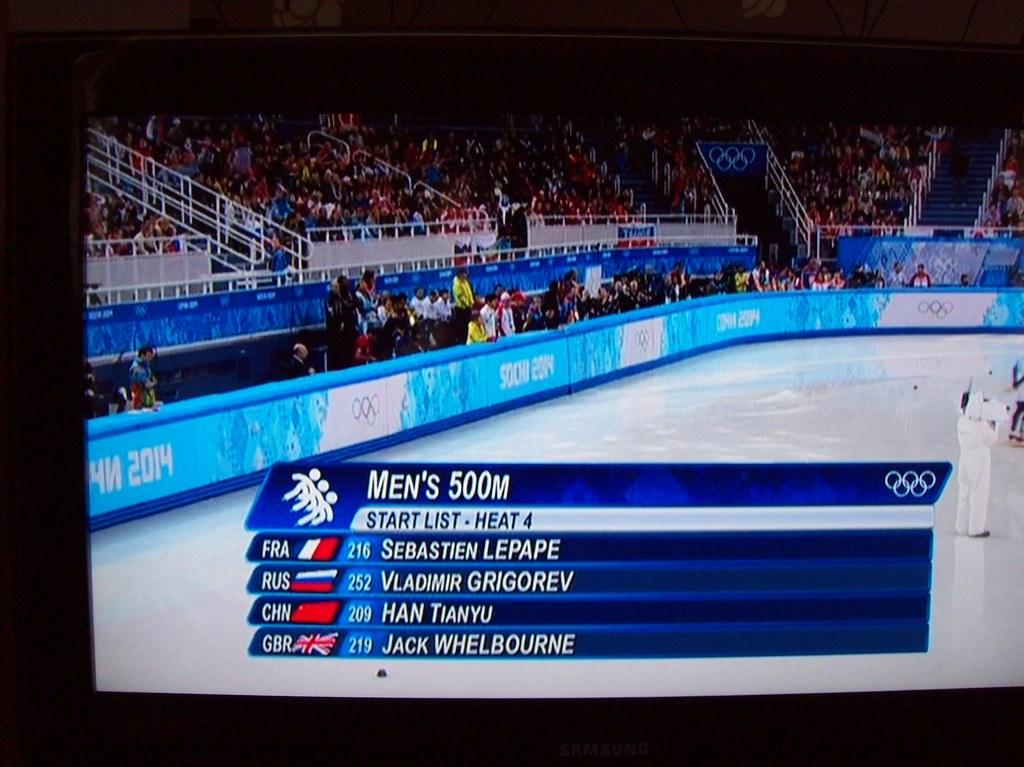<image>
Give a short and clear explanation of the subsequent image. Men's 500m olympic skating with france in first place followed by russia, china and england. 